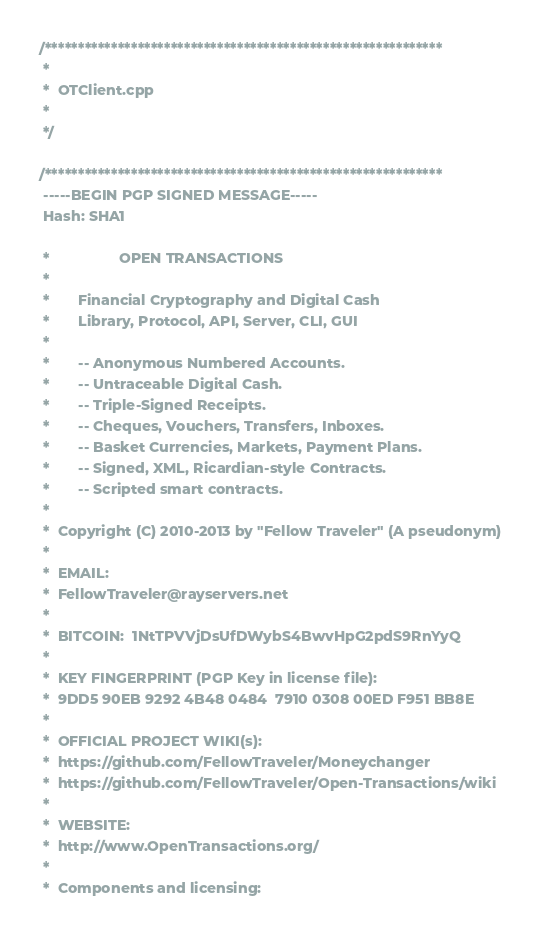<code> <loc_0><loc_0><loc_500><loc_500><_C++_>/************************************************************
 *
 *  OTClient.cpp
 *
 */

/************************************************************
 -----BEGIN PGP SIGNED MESSAGE-----
 Hash: SHA1

 *                 OPEN TRANSACTIONS
 *
 *       Financial Cryptography and Digital Cash
 *       Library, Protocol, API, Server, CLI, GUI
 *
 *       -- Anonymous Numbered Accounts.
 *       -- Untraceable Digital Cash.
 *       -- Triple-Signed Receipts.
 *       -- Cheques, Vouchers, Transfers, Inboxes.
 *       -- Basket Currencies, Markets, Payment Plans.
 *       -- Signed, XML, Ricardian-style Contracts.
 *       -- Scripted smart contracts.
 *
 *  Copyright (C) 2010-2013 by "Fellow Traveler" (A pseudonym)
 *
 *  EMAIL:
 *  FellowTraveler@rayservers.net
 *
 *  BITCOIN:  1NtTPVVjDsUfDWybS4BwvHpG2pdS9RnYyQ
 *
 *  KEY FINGERPRINT (PGP Key in license file):
 *  9DD5 90EB 9292 4B48 0484  7910 0308 00ED F951 BB8E
 *
 *  OFFICIAL PROJECT WIKI(s):
 *  https://github.com/FellowTraveler/Moneychanger
 *  https://github.com/FellowTraveler/Open-Transactions/wiki
 *
 *  WEBSITE:
 *  http://www.OpenTransactions.org/
 *
 *  Components and licensing:</code> 